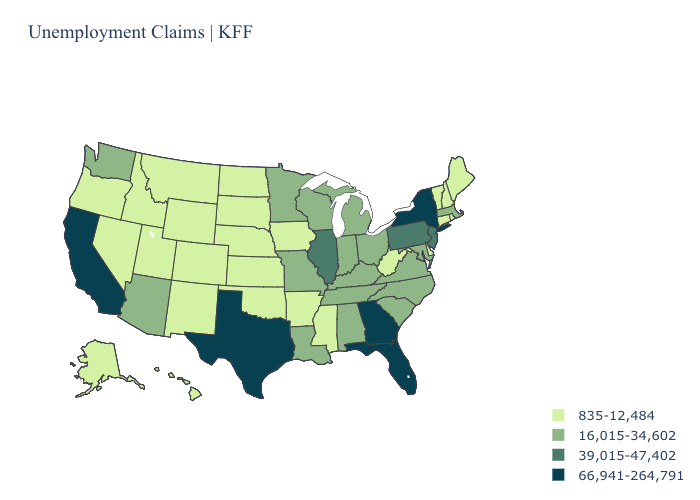What is the lowest value in the Northeast?
Concise answer only. 835-12,484. What is the value of Illinois?
Quick response, please. 39,015-47,402. Does the first symbol in the legend represent the smallest category?
Be succinct. Yes. Does Kentucky have the lowest value in the USA?
Give a very brief answer. No. Which states have the lowest value in the West?
Be succinct. Alaska, Colorado, Hawaii, Idaho, Montana, Nevada, New Mexico, Oregon, Utah, Wyoming. Name the states that have a value in the range 16,015-34,602?
Be succinct. Alabama, Arizona, Indiana, Kentucky, Louisiana, Maryland, Massachusetts, Michigan, Minnesota, Missouri, North Carolina, Ohio, South Carolina, Tennessee, Virginia, Washington, Wisconsin. What is the highest value in states that border South Dakota?
Concise answer only. 16,015-34,602. Name the states that have a value in the range 66,941-264,791?
Quick response, please. California, Florida, Georgia, New York, Texas. Does the map have missing data?
Short answer required. No. Among the states that border New Jersey , does Delaware have the lowest value?
Keep it brief. Yes. Does Texas have the highest value in the South?
Quick response, please. Yes. Is the legend a continuous bar?
Write a very short answer. No. Does Arizona have the lowest value in the West?
Be succinct. No. Name the states that have a value in the range 16,015-34,602?
Short answer required. Alabama, Arizona, Indiana, Kentucky, Louisiana, Maryland, Massachusetts, Michigan, Minnesota, Missouri, North Carolina, Ohio, South Carolina, Tennessee, Virginia, Washington, Wisconsin. Does Virginia have a lower value than California?
Be succinct. Yes. 